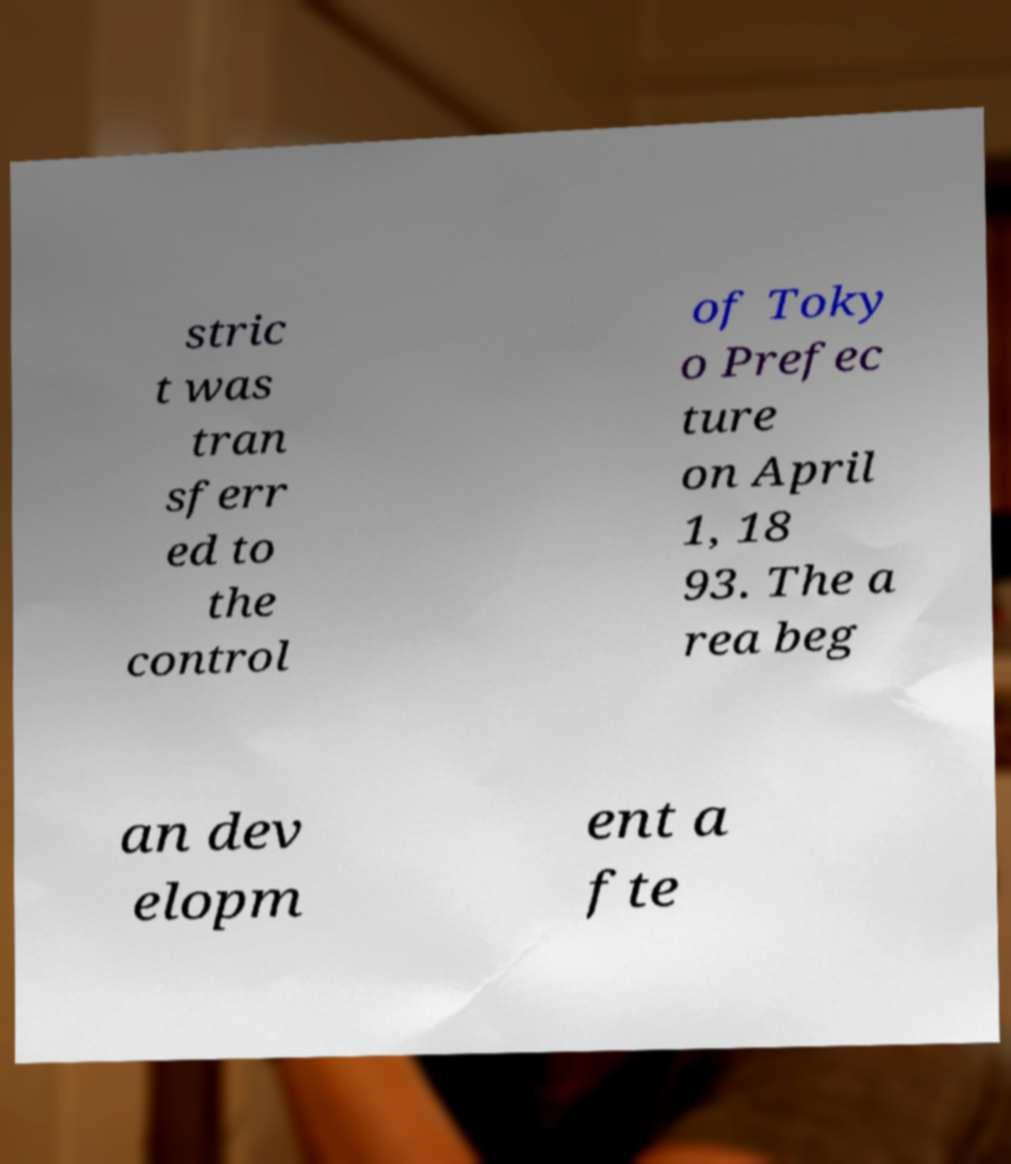What messages or text are displayed in this image? I need them in a readable, typed format. stric t was tran sferr ed to the control of Toky o Prefec ture on April 1, 18 93. The a rea beg an dev elopm ent a fte 